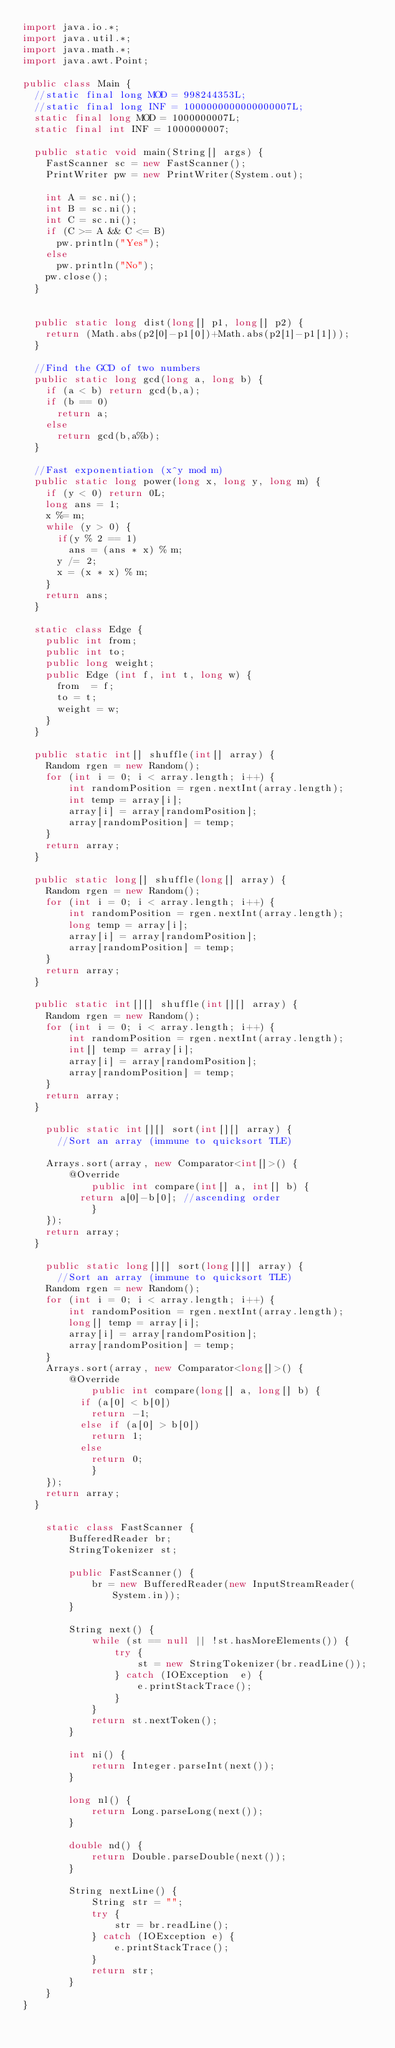Convert code to text. <code><loc_0><loc_0><loc_500><loc_500><_Java_>import java.io.*;
import java.util.*;
import java.math.*;
import java.awt.Point;
 
public class Main {
	//static final long MOD = 998244353L;
	//static final long INF = 1000000000000000007L;
	static final long MOD = 1000000007L;
	static final int INF = 1000000007;

	public static void main(String[] args) {
		FastScanner sc = new FastScanner();
		PrintWriter pw = new PrintWriter(System.out);
		
		int A = sc.ni();
		int B = sc.ni();
		int C = sc.ni();
		if (C >= A && C <= B)
			pw.println("Yes");
		else
			pw.println("No");
		pw.close();
	}

 
	public static long dist(long[] p1, long[] p2) {
		return (Math.abs(p2[0]-p1[0])+Math.abs(p2[1]-p1[1]));
	}
	
	//Find the GCD of two numbers
	public static long gcd(long a, long b) {
		if (a < b) return gcd(b,a);
		if (b == 0)
			return a;
		else
			return gcd(b,a%b);
	}
	
	//Fast exponentiation (x^y mod m)
	public static long power(long x, long y, long m) { 
		if (y < 0) return 0L;
		long ans = 1;
		x %= m;
		while (y > 0) { 
			if(y % 2 == 1) 
				ans = (ans * x) % m; 
			y /= 2;  
			x = (x * x) % m;
		} 
		return ans; 
	}
	
	static class Edge {
		public int from;
		public int to;
		public long weight;
		public Edge (int f, int t, long w) {
			from  = f;
			to = t;
			weight = w;
		}
	}
	
	public static int[] shuffle(int[] array) {
		Random rgen = new Random();
		for (int i = 0; i < array.length; i++) {
		    int randomPosition = rgen.nextInt(array.length);
		    int temp = array[i];
		    array[i] = array[randomPosition];
		    array[randomPosition] = temp;
		}
		return array;
	}
	
	public static long[] shuffle(long[] array) {
		Random rgen = new Random();
		for (int i = 0; i < array.length; i++) {
		    int randomPosition = rgen.nextInt(array.length);
		    long temp = array[i];
		    array[i] = array[randomPosition];
		    array[randomPosition] = temp;
		}
		return array;
	}
	
	public static int[][] shuffle(int[][] array) {
		Random rgen = new Random();
		for (int i = 0; i < array.length; i++) {
		    int randomPosition = rgen.nextInt(array.length);
		    int[] temp = array[i];
		    array[i] = array[randomPosition];
		    array[randomPosition] = temp;
		}
		return array;
	}
	
    public static int[][] sort(int[][] array) {
    	//Sort an array (immune to quicksort TLE)
 
		Arrays.sort(array, new Comparator<int[]>() {
			  @Override
        	  public int compare(int[] a, int[] b) {
				  return a[0]-b[0]; //ascending order
	          }
		});
		return array;
	}
    
    public static long[][] sort(long[][] array) {
    	//Sort an array (immune to quicksort TLE)
		Random rgen = new Random();
		for (int i = 0; i < array.length; i++) {
		    int randomPosition = rgen.nextInt(array.length);
		    long[] temp = array[i];
		    array[i] = array[randomPosition];
		    array[randomPosition] = temp;
		}
		Arrays.sort(array, new Comparator<long[]>() {
			  @Override
        	  public int compare(long[] a, long[] b) {
				  if (a[0] < b[0])
					  return -1;
				  else if (a[0] > b[0])
					  return 1;
				  else
					  return 0;
	          }
		});
		return array;
	}
    
    static class FastScanner { 
        BufferedReader br; 
        StringTokenizer st; 
  
        public FastScanner() { 
            br = new BufferedReader(new InputStreamReader(System.in)); 
        } 
  
        String next() { 
            while (st == null || !st.hasMoreElements()) { 
                try { 
                    st = new StringTokenizer(br.readLine());
                } catch (IOException  e) { 
                    e.printStackTrace(); 
                } 
            } 
            return st.nextToken(); 
        }
        
        int ni() { 
            return Integer.parseInt(next()); 
        }
  
        long nl() { 
            return Long.parseLong(next()); 
        } 
  
        double nd() { 
            return Double.parseDouble(next()); 
        } 
  
        String nextLine() {
            String str = ""; 
            try { 
                str = br.readLine(); 
            } catch (IOException e) {
                e.printStackTrace(); 
            } 
            return str;
        }
    }
}</code> 